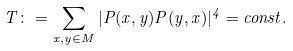Convert formula to latex. <formula><loc_0><loc_0><loc_500><loc_500>T \colon = \sum _ { x , y \in M } | P ( x , y ) P ( y , x ) | ^ { 4 } = c o n s t .</formula> 